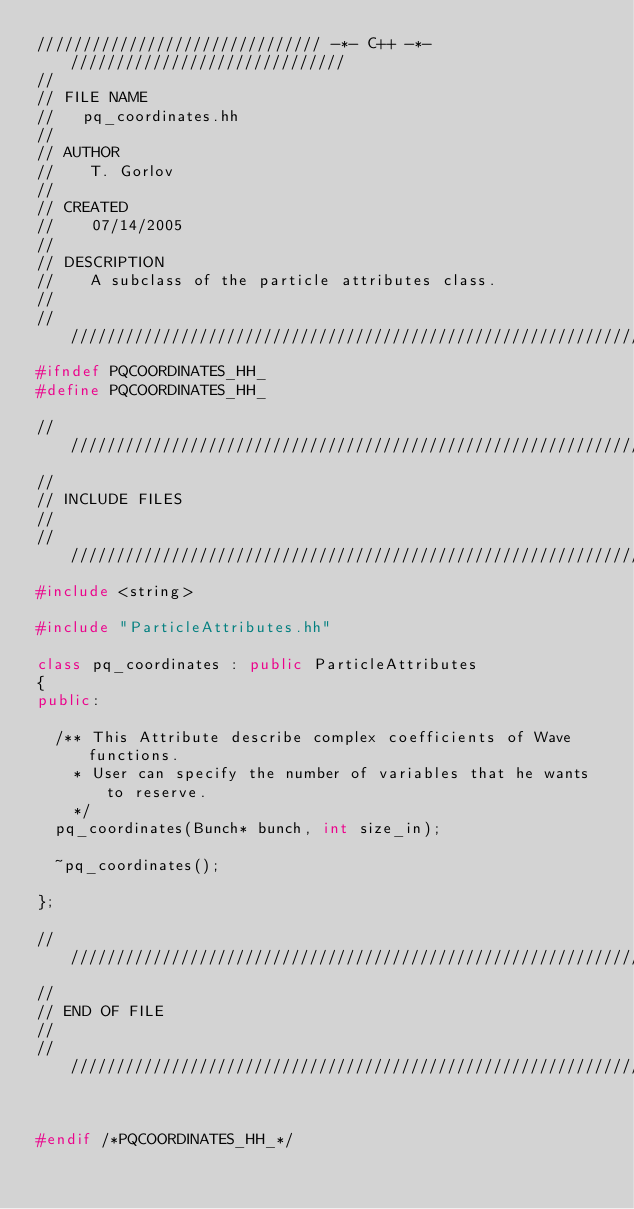<code> <loc_0><loc_0><loc_500><loc_500><_C++_>/////////////////////////////// -*- C++ -*- //////////////////////////////
//
// FILE NAME
//   pq_coordinates.hh
//
// AUTHOR
//    T. Gorlov
//
// CREATED
//    07/14/2005
//
// DESCRIPTION
//    A subclass of the particle attributes class. 
//
///////////////////////////////////////////////////////////////////////////
#ifndef PQCOORDINATES_HH_
#define PQCOORDINATES_HH_

///////////////////////////////////////////////////////////////////////////
//
// INCLUDE FILES
//
///////////////////////////////////////////////////////////////////////////
#include <string>

#include "ParticleAttributes.hh"

class pq_coordinates : public ParticleAttributes
{
public:
	
	/** This Attribute describe complex coefficients of Wave functions.
	  * User can specify the number of variables that he wants to reserve.
		*/
	pq_coordinates(Bunch* bunch, int size_in);
	
  ~pq_coordinates();

};

///////////////////////////////////////////////////////////////////////////
//
// END OF FILE
//
///////////////////////////////////////////////////////////////////////////


#endif /*PQCOORDINATES_HH_*/
</code> 